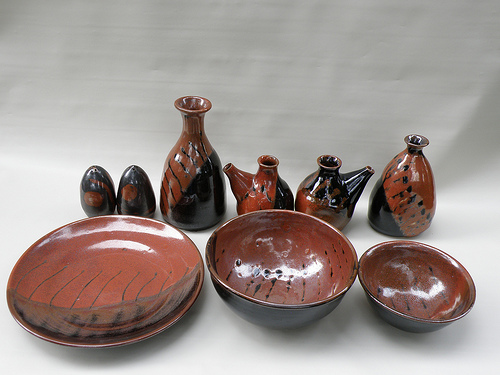Please provide the bounding box coordinate of the region this sentence describes: A red bowl with black streaks on the glaze. The coordinates for the 'red bowl with black streaks on the glaze' are [0.41, 0.54, 0.7, 0.79]. This bowl features a unique, artistic glaze that draws attention. 